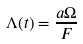<formula> <loc_0><loc_0><loc_500><loc_500>\Lambda ( t ) = \frac { a \Omega } F</formula> 